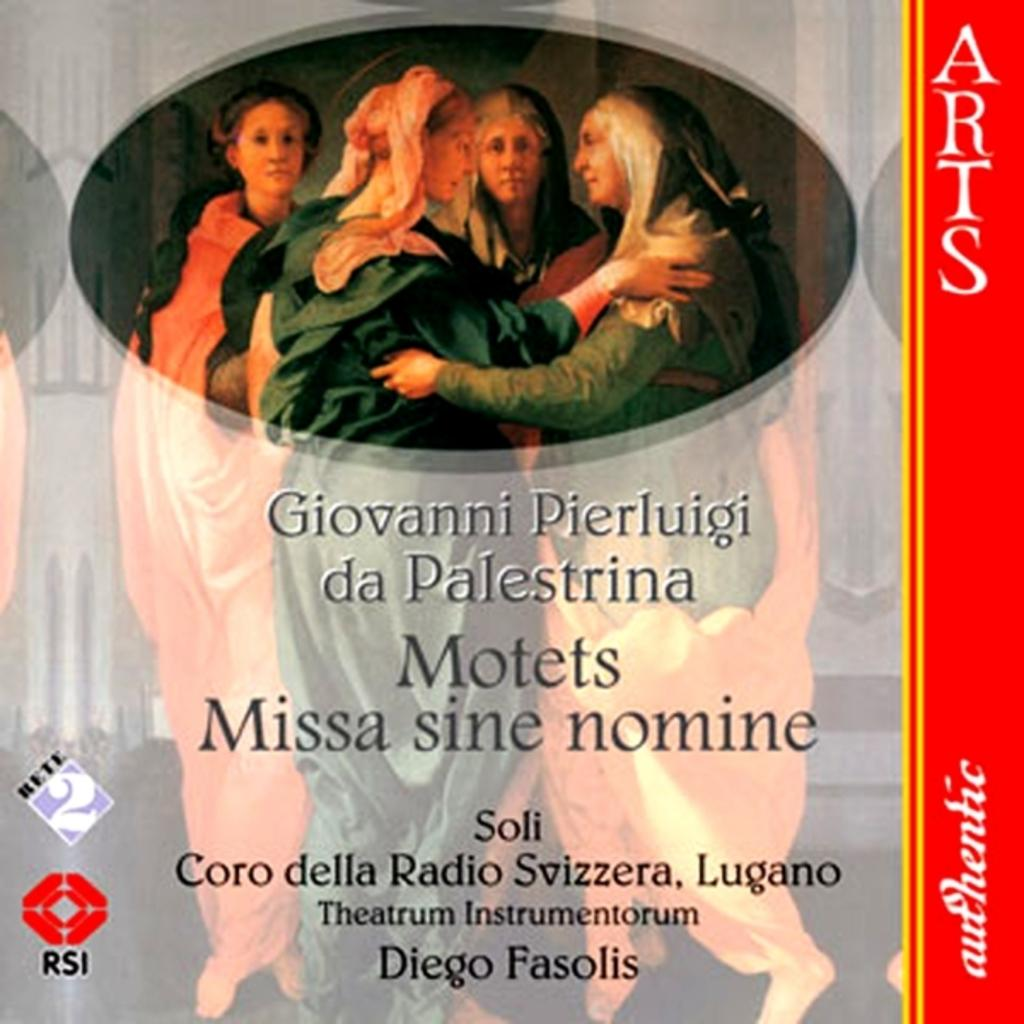<image>
Provide a brief description of the given image. Missa sine nomine literally means "Mass without a name." 